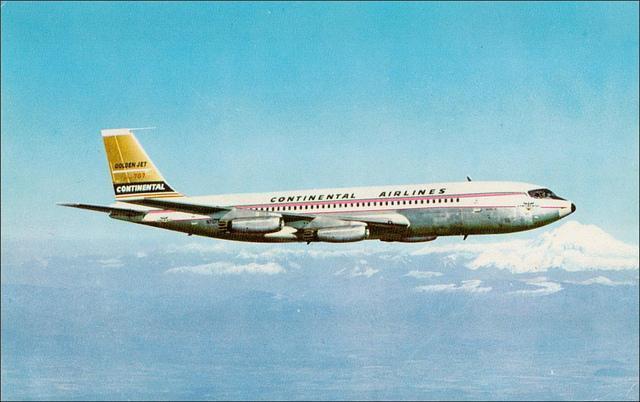How many planes in the air?
Give a very brief answer. 1. 